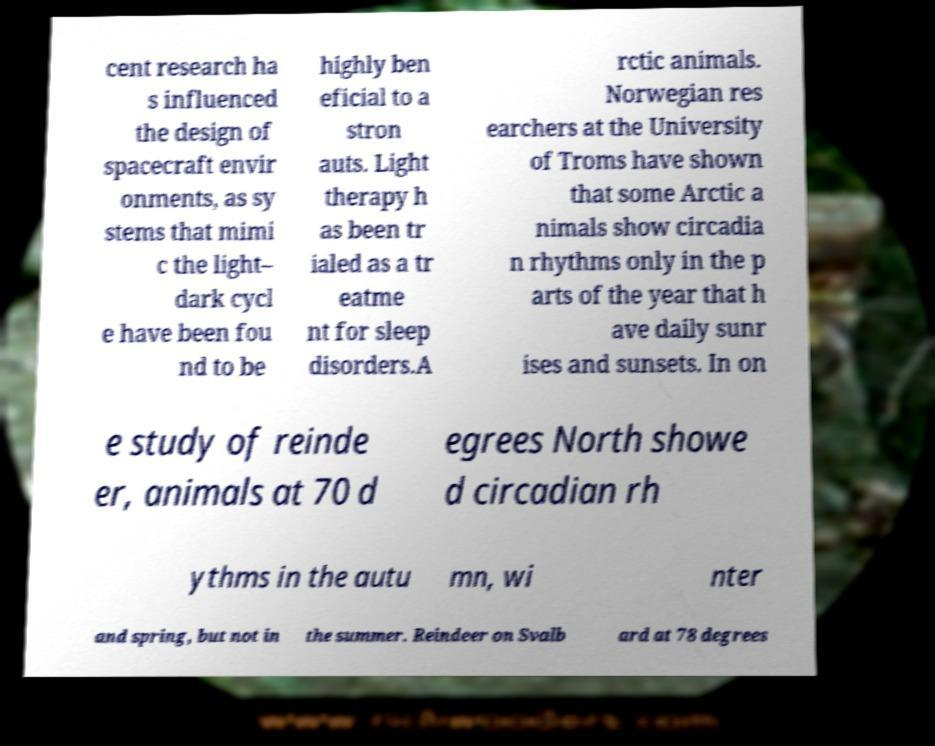Could you assist in decoding the text presented in this image and type it out clearly? cent research ha s influenced the design of spacecraft envir onments, as sy stems that mimi c the light– dark cycl e have been fou nd to be highly ben eficial to a stron auts. Light therapy h as been tr ialed as a tr eatme nt for sleep disorders.A rctic animals. Norwegian res earchers at the University of Troms have shown that some Arctic a nimals show circadia n rhythms only in the p arts of the year that h ave daily sunr ises and sunsets. In on e study of reinde er, animals at 70 d egrees North showe d circadian rh ythms in the autu mn, wi nter and spring, but not in the summer. Reindeer on Svalb ard at 78 degrees 